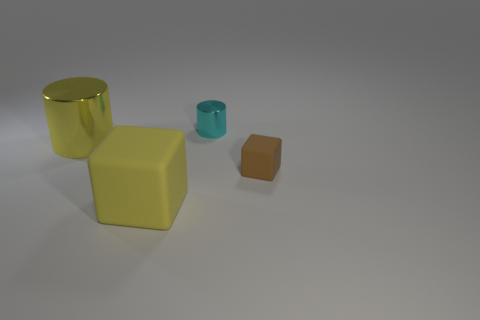What is the material of the thing that is the same size as the yellow block?
Offer a very short reply. Metal. Does the cylinder on the left side of the large yellow matte cube have the same color as the matte object that is in front of the small cube?
Provide a short and direct response. Yes. Is the tiny brown object made of the same material as the large yellow cylinder?
Offer a very short reply. No. The yellow matte block has what size?
Offer a terse response. Large. What is the shape of the metal thing to the left of the small cyan cylinder?
Offer a terse response. Cylinder. Is the shape of the small shiny object the same as the large yellow shiny thing?
Give a very brief answer. Yes. Are there the same number of small blocks that are to the left of the tiny cylinder and small cyan metallic cylinders?
Offer a terse response. No. There is a small brown rubber thing; what shape is it?
Your answer should be compact. Cube. Is there anything else that has the same color as the tiny metal thing?
Offer a very short reply. No. Is the size of the yellow thing that is to the left of the large matte block the same as the yellow object in front of the yellow shiny thing?
Provide a succinct answer. Yes. 